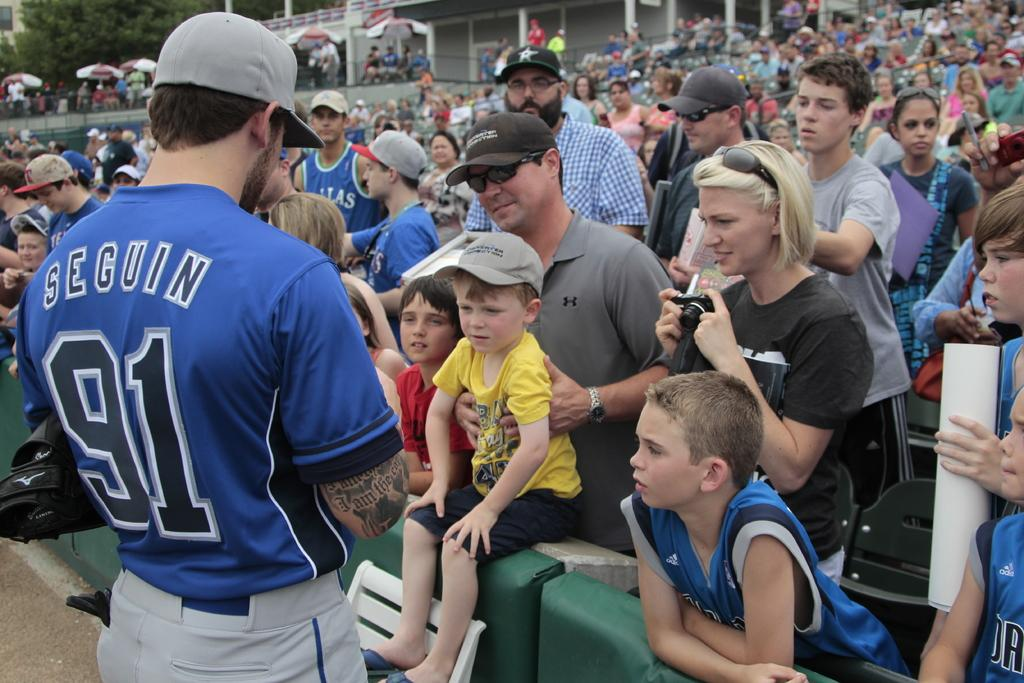<image>
Create a compact narrative representing the image presented. the player who has secuin  91 as in jersey standing in front of the audience 